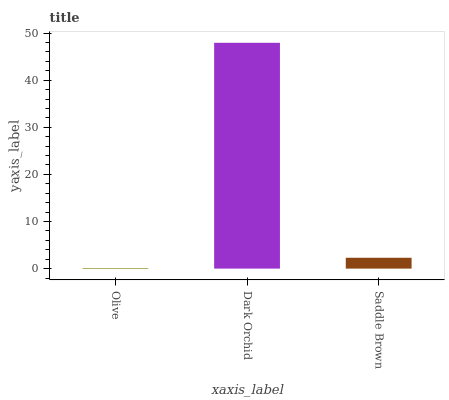Is Saddle Brown the minimum?
Answer yes or no. No. Is Saddle Brown the maximum?
Answer yes or no. No. Is Dark Orchid greater than Saddle Brown?
Answer yes or no. Yes. Is Saddle Brown less than Dark Orchid?
Answer yes or no. Yes. Is Saddle Brown greater than Dark Orchid?
Answer yes or no. No. Is Dark Orchid less than Saddle Brown?
Answer yes or no. No. Is Saddle Brown the high median?
Answer yes or no. Yes. Is Saddle Brown the low median?
Answer yes or no. Yes. Is Dark Orchid the high median?
Answer yes or no. No. Is Olive the low median?
Answer yes or no. No. 